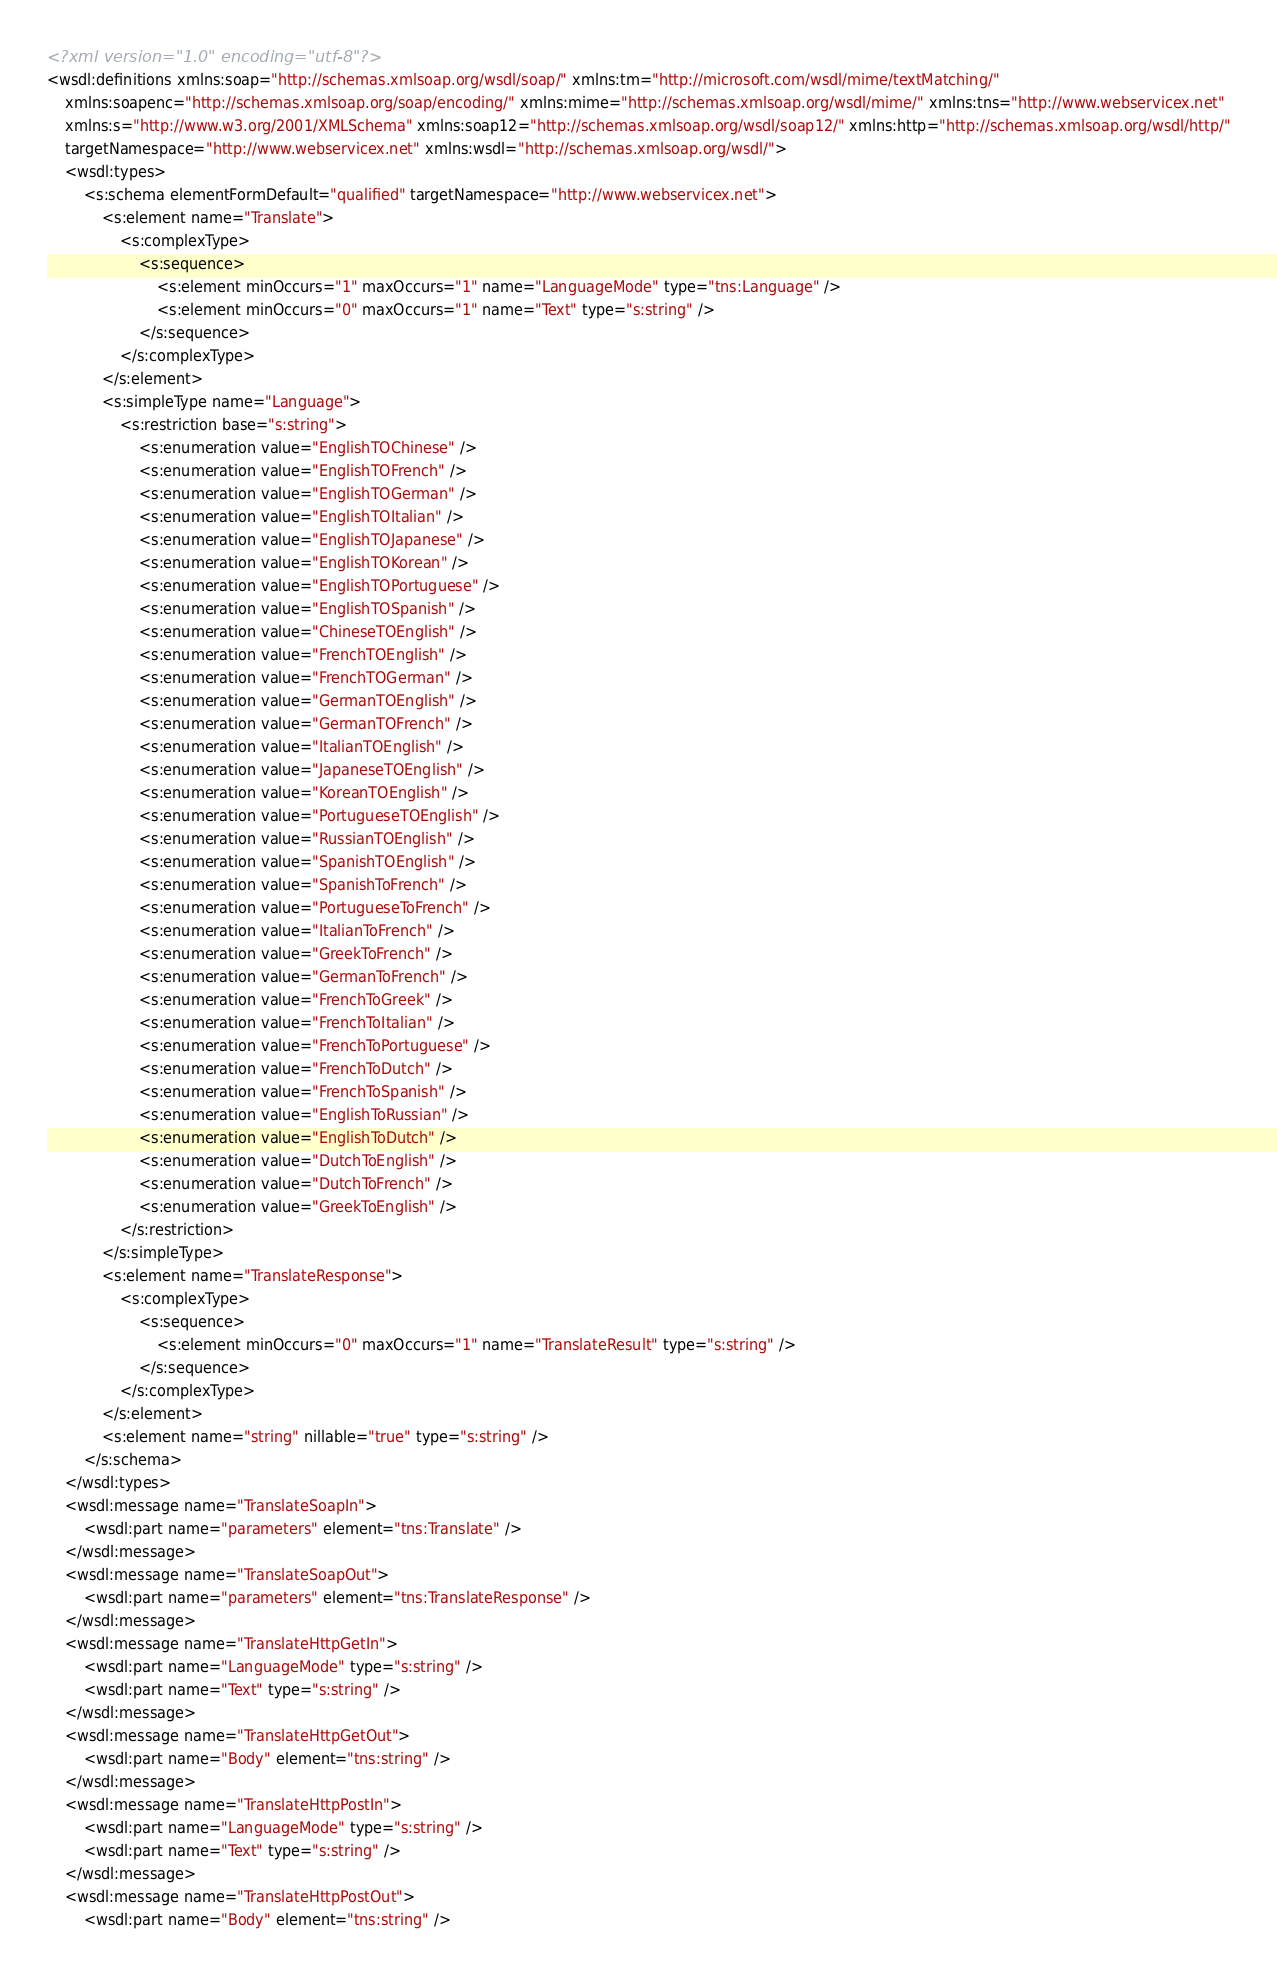<code> <loc_0><loc_0><loc_500><loc_500><_XML_><?xml version="1.0" encoding="utf-8"?>
<wsdl:definitions xmlns:soap="http://schemas.xmlsoap.org/wsdl/soap/" xmlns:tm="http://microsoft.com/wsdl/mime/textMatching/"
	xmlns:soapenc="http://schemas.xmlsoap.org/soap/encoding/" xmlns:mime="http://schemas.xmlsoap.org/wsdl/mime/" xmlns:tns="http://www.webservicex.net"
	xmlns:s="http://www.w3.org/2001/XMLSchema" xmlns:soap12="http://schemas.xmlsoap.org/wsdl/soap12/" xmlns:http="http://schemas.xmlsoap.org/wsdl/http/"
	targetNamespace="http://www.webservicex.net" xmlns:wsdl="http://schemas.xmlsoap.org/wsdl/">
	<wsdl:types>
		<s:schema elementFormDefault="qualified" targetNamespace="http://www.webservicex.net">
			<s:element name="Translate">
				<s:complexType>
					<s:sequence>
						<s:element minOccurs="1" maxOccurs="1" name="LanguageMode" type="tns:Language" />
						<s:element minOccurs="0" maxOccurs="1" name="Text" type="s:string" />
					</s:sequence>
				</s:complexType>
			</s:element>
			<s:simpleType name="Language">
				<s:restriction base="s:string">
					<s:enumeration value="EnglishTOChinese" />
					<s:enumeration value="EnglishTOFrench" />
					<s:enumeration value="EnglishTOGerman" />
					<s:enumeration value="EnglishTOItalian" />
					<s:enumeration value="EnglishTOJapanese" />
					<s:enumeration value="EnglishTOKorean" />
					<s:enumeration value="EnglishTOPortuguese" />
					<s:enumeration value="EnglishTOSpanish" />
					<s:enumeration value="ChineseTOEnglish" />
					<s:enumeration value="FrenchTOEnglish" />
					<s:enumeration value="FrenchTOGerman" />
					<s:enumeration value="GermanTOEnglish" />
					<s:enumeration value="GermanTOFrench" />
					<s:enumeration value="ItalianTOEnglish" />
					<s:enumeration value="JapaneseTOEnglish" />
					<s:enumeration value="KoreanTOEnglish" />
					<s:enumeration value="PortugueseTOEnglish" />
					<s:enumeration value="RussianTOEnglish" />
					<s:enumeration value="SpanishTOEnglish" />
					<s:enumeration value="SpanishToFrench" />
					<s:enumeration value="PortugueseToFrench" />
					<s:enumeration value="ItalianToFrench" />
					<s:enumeration value="GreekToFrench" />
					<s:enumeration value="GermanToFrench" />
					<s:enumeration value="FrenchToGreek" />
					<s:enumeration value="FrenchToItalian" />
					<s:enumeration value="FrenchToPortuguese" />
					<s:enumeration value="FrenchToDutch" />
					<s:enumeration value="FrenchToSpanish" />
					<s:enumeration value="EnglishToRussian" />
					<s:enumeration value="EnglishToDutch" />
					<s:enumeration value="DutchToEnglish" />
					<s:enumeration value="DutchToFrench" />
					<s:enumeration value="GreekToEnglish" />
				</s:restriction>
			</s:simpleType>
			<s:element name="TranslateResponse">
				<s:complexType>
					<s:sequence>
						<s:element minOccurs="0" maxOccurs="1" name="TranslateResult" type="s:string" />
					</s:sequence>
				</s:complexType>
			</s:element>
			<s:element name="string" nillable="true" type="s:string" />
		</s:schema>
	</wsdl:types>
	<wsdl:message name="TranslateSoapIn">
		<wsdl:part name="parameters" element="tns:Translate" />
	</wsdl:message>
	<wsdl:message name="TranslateSoapOut">
		<wsdl:part name="parameters" element="tns:TranslateResponse" />
	</wsdl:message>
	<wsdl:message name="TranslateHttpGetIn">
		<wsdl:part name="LanguageMode" type="s:string" />
		<wsdl:part name="Text" type="s:string" />
	</wsdl:message>
	<wsdl:message name="TranslateHttpGetOut">
		<wsdl:part name="Body" element="tns:string" />
	</wsdl:message>
	<wsdl:message name="TranslateHttpPostIn">
		<wsdl:part name="LanguageMode" type="s:string" />
		<wsdl:part name="Text" type="s:string" />
	</wsdl:message>
	<wsdl:message name="TranslateHttpPostOut">
		<wsdl:part name="Body" element="tns:string" /></code> 